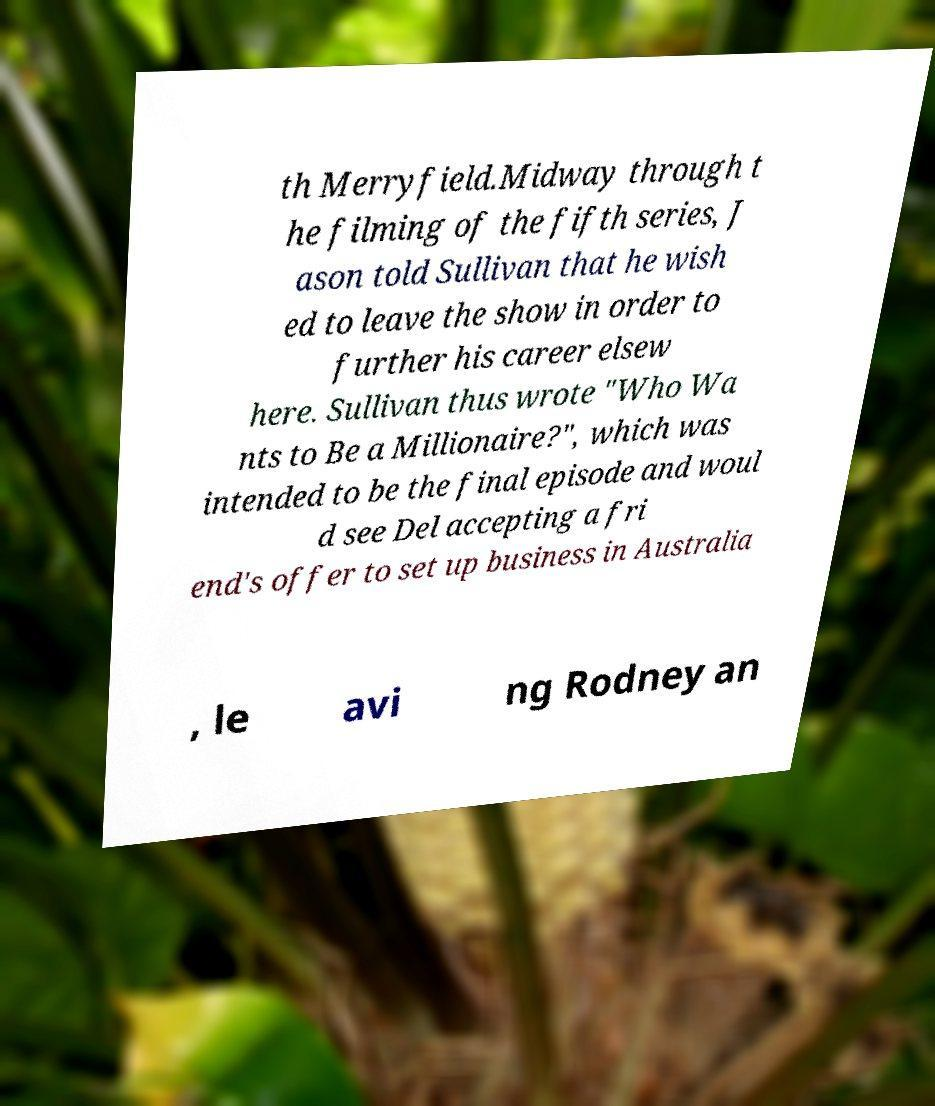What messages or text are displayed in this image? I need them in a readable, typed format. th Merryfield.Midway through t he filming of the fifth series, J ason told Sullivan that he wish ed to leave the show in order to further his career elsew here. Sullivan thus wrote "Who Wa nts to Be a Millionaire?", which was intended to be the final episode and woul d see Del accepting a fri end's offer to set up business in Australia , le avi ng Rodney an 